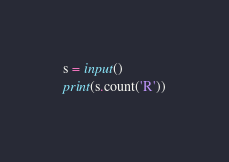<code> <loc_0><loc_0><loc_500><loc_500><_Python_>s = input()
print(s.count('R'))</code> 